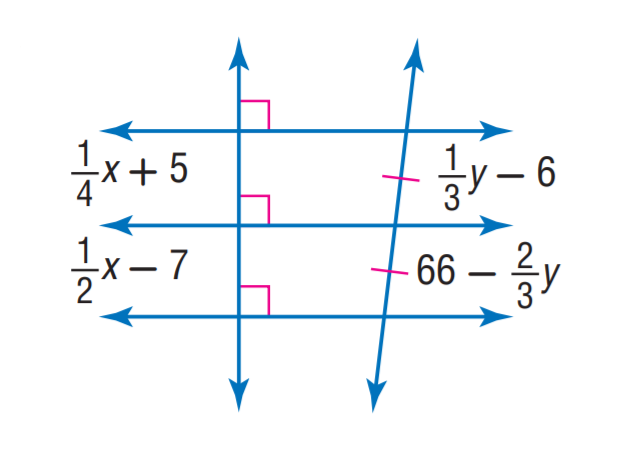Question: Find x.
Choices:
A. 36
B. 48
C. 66
D. 72
Answer with the letter. Answer: B Question: Find y.
Choices:
A. 36
B. 48
C. 66
D. 72
Answer with the letter. Answer: D 